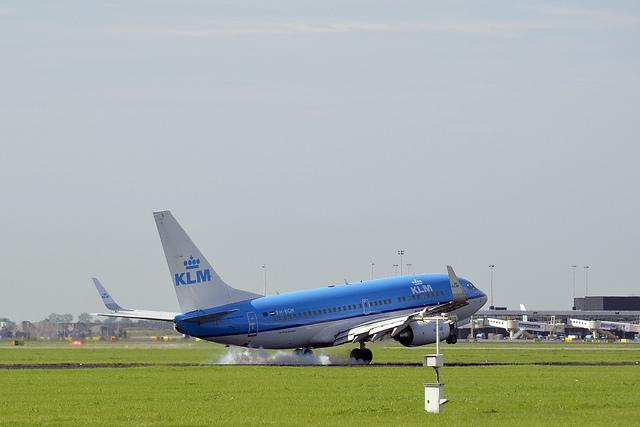What is the primary color of the plane?
Short answer required. Blue. Is that a military plane?
Be succinct. No. Is the plane landing?
Write a very short answer. Yes. What color is this plane?
Answer briefly. Blue. What airline does this plane belong to?
Quick response, please. Klm. What letter is on the tail?
Quick response, please. Klm. What color is the plane?
Concise answer only. Blue and white. What is the plane sitting on?
Be succinct. Runway. What colors are the plane?
Answer briefly. Blue and white. IS the plane landing or taking off?
Write a very short answer. Landing. How many exits are shown?
Quick response, please. 2. Could this be an Air Force plane?
Concise answer only. No. Is this plane landing or taking off?
Short answer required. Taking off. What is the speed of this airplane?
Write a very short answer. 300 mph. Is the photograph taken from inside the plane?
Keep it brief. No. Is the plane taking off or landing?
Be succinct. Taking off. What is written on the plane?
Short answer required. Klm. What military function is this built for?
Give a very brief answer. Flying. 